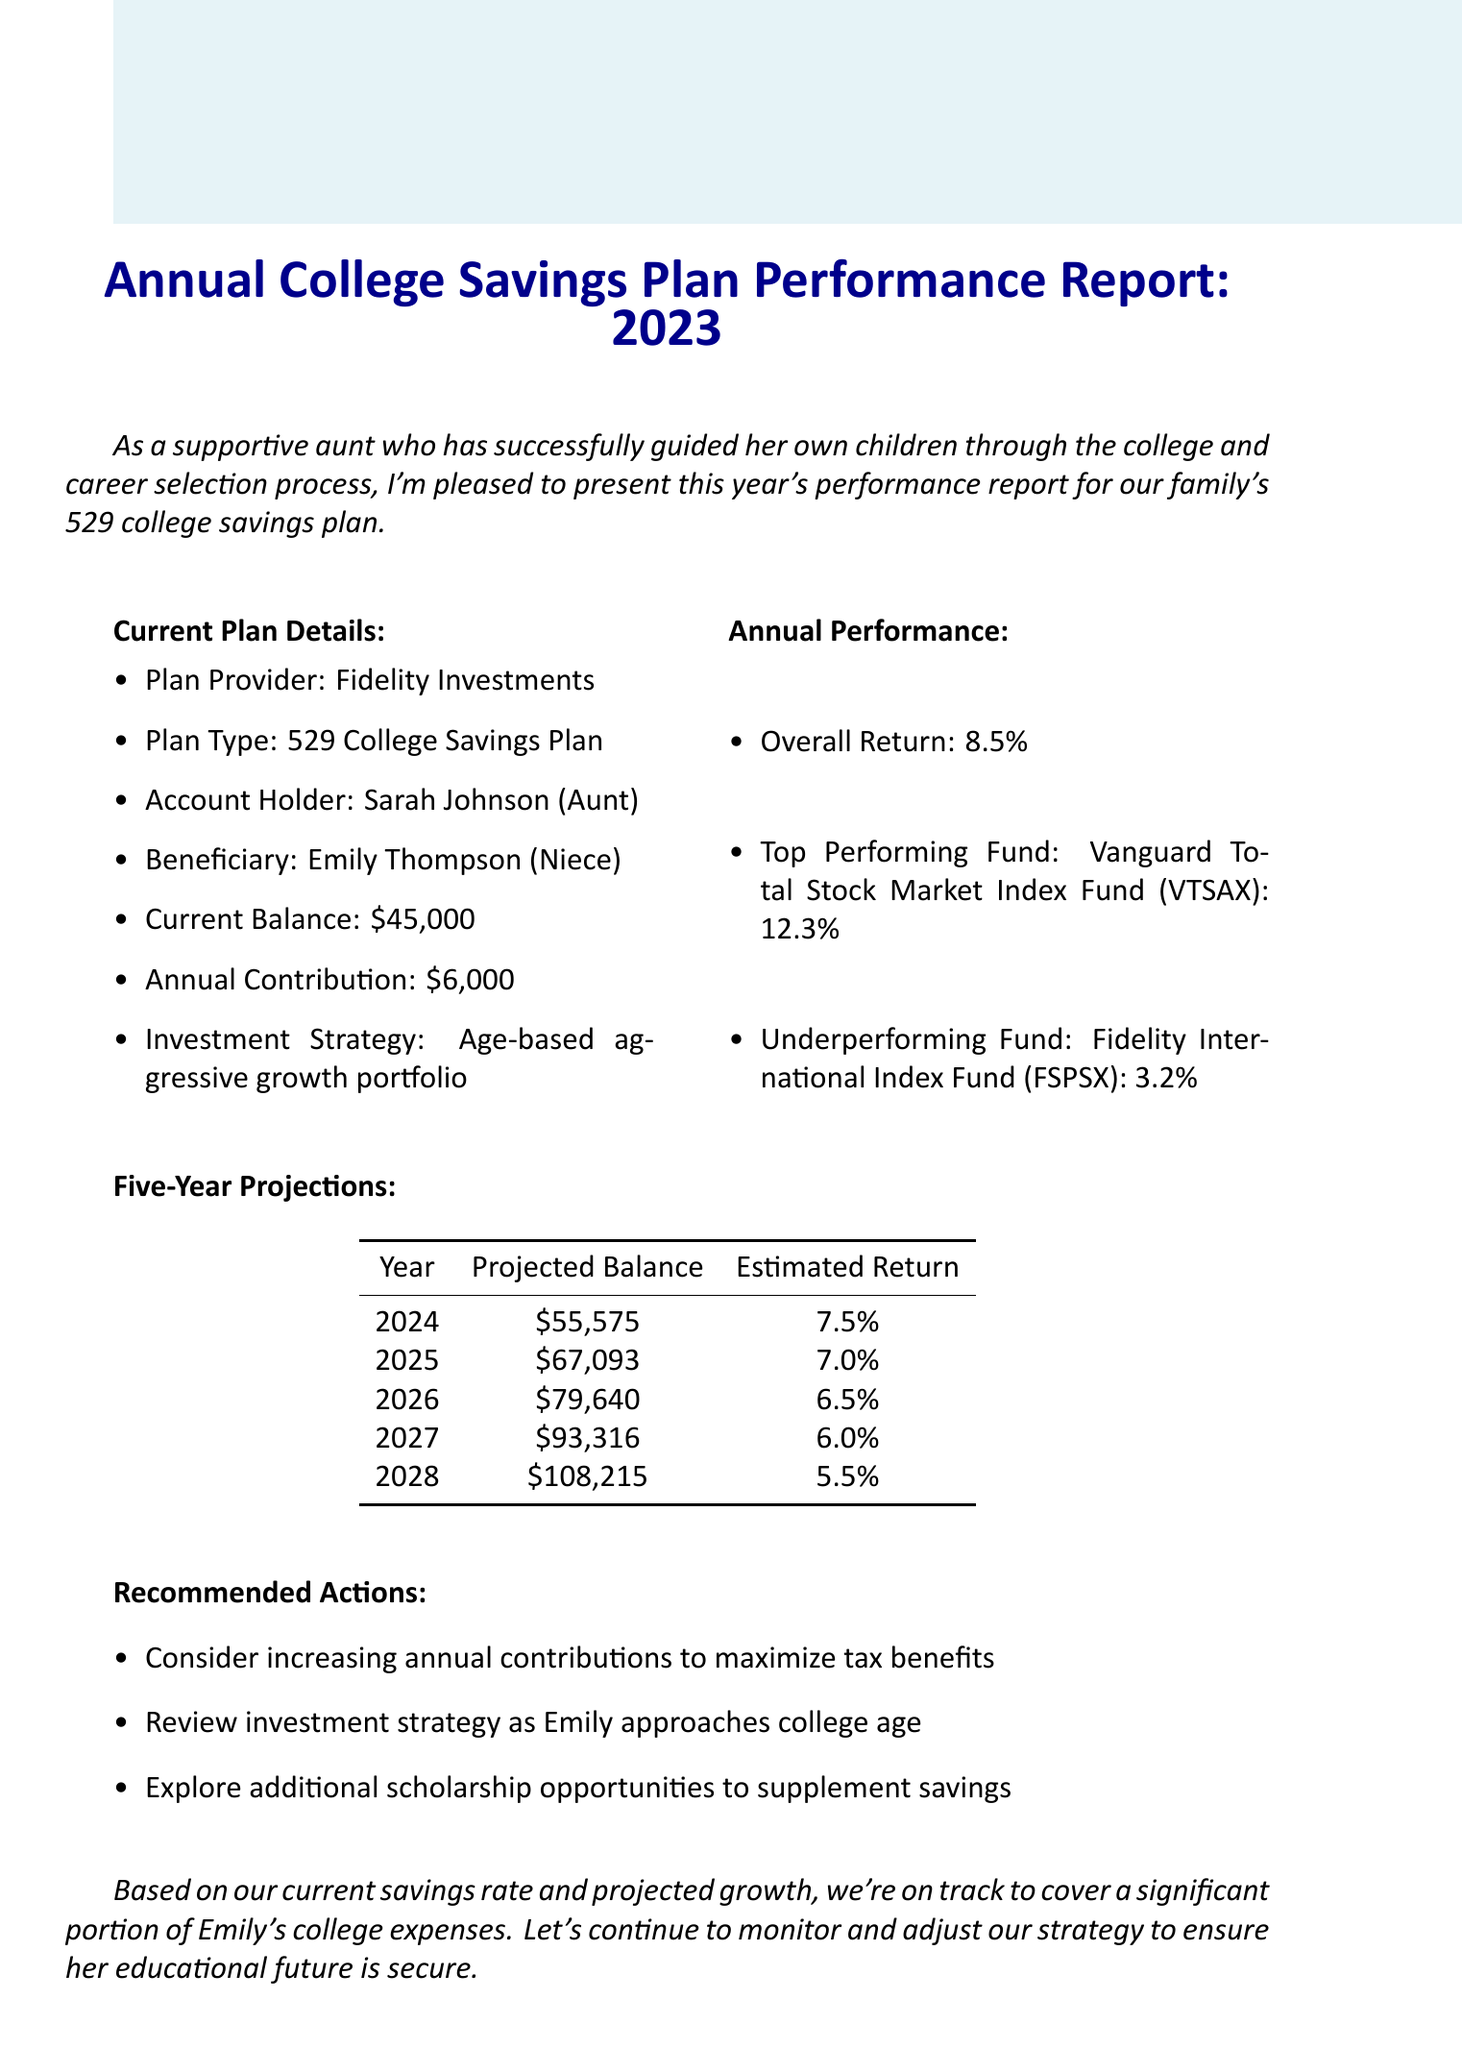What is the plan provider? The plan provider is listed under the Current Plan Details section of the document.
Answer: Fidelity Investments What is the current balance of the account? The current balance can be found in the Current Plan Details section.
Answer: $45,000 What was the overall return for the year? The overall return is stated in the Annual Performance section.
Answer: 8.5% What is the projected balance for the year 2026? The projected balance is in the Five-Year Projections table for the year 2026.
Answer: $79,640 What is the recommended action regarding annual contributions? Recommended actions are listed in the Recommended Actions section.
Answer: Consider increasing annual contributions to maximize tax benefits Which fund underperformed in the past year? The underperforming fund is mentioned in the Annual Performance section.
Answer: Fidelity International Index Fund (FSPSX) What is the estimated return for the year 2028? This information is found in the Five-Year Projections table for the year 2028.
Answer: 5.5% How much is the annual contribution to the plan? The annual contribution can be found in the Current Plan Details section.
Answer: $6,000 Who is the beneficiary of the college savings plan? The beneficiary's name is mentioned in the Current Plan Details section.
Answer: Emily Thompson 